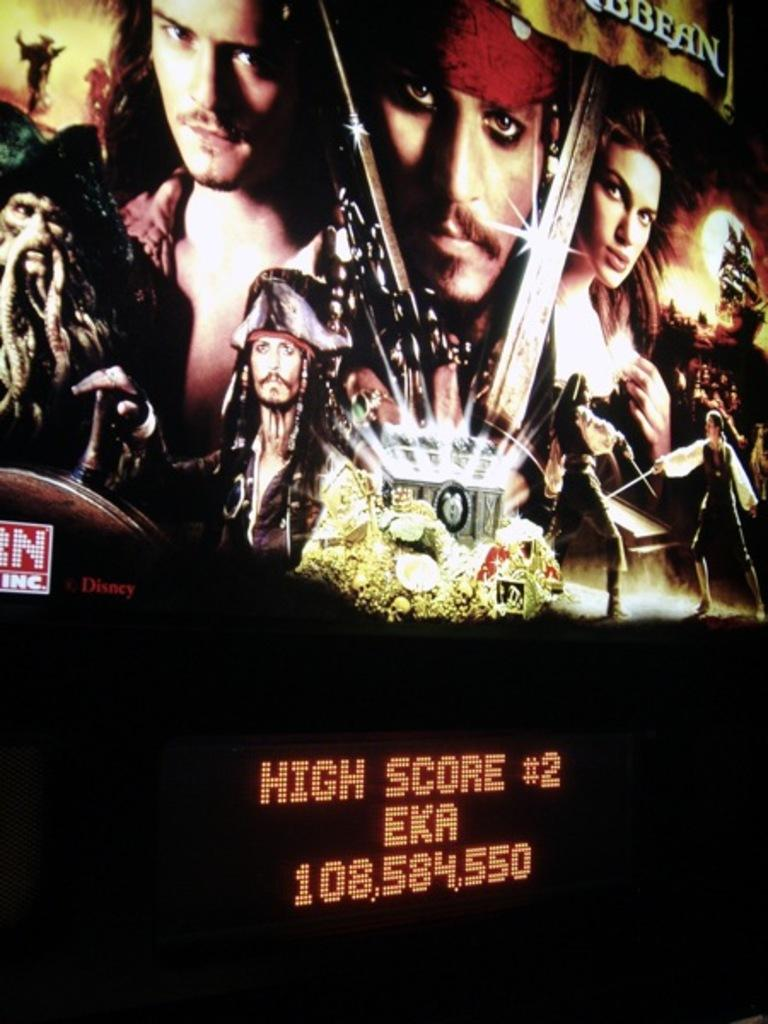<image>
Render a clear and concise summary of the photo. A Pirates of the Caribbean poster with a neon sign below it that says High Score #2 EKA 108,584,5500 